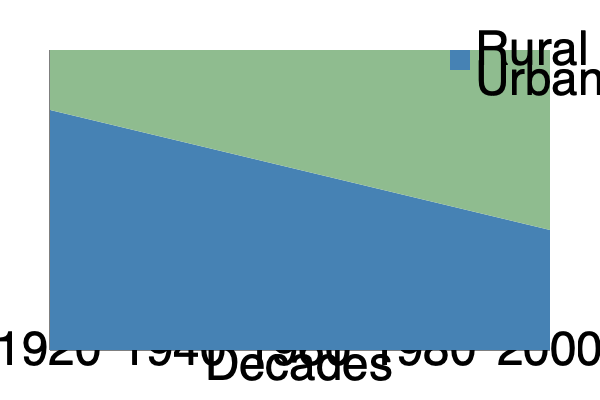Based on the stacked area chart showing the distribution of urban and rural populations from 1920 to 2000, which decade marked the turning point when the urban population surpassed the rural population in the United States? To determine when the urban population surpassed the rural population, we need to analyze the chart decade by decade:

1. 1920: The rural population (blue) is significantly larger than the urban population (green).
2. 1940: The rural population is still larger, but the gap has narrowed.
3. 1960: This appears to be the critical point. The two areas are roughly equal, with the urban area slightly larger.
4. 1980 and 2000: The urban population clearly exceeds the rural population.

The crossover point occurs around 1960, which aligns with historical data. The 1960 census was indeed the first time the urban population officially surpassed the rural population in the United States.

This shift reflects the significant demographic changes that occurred in the mid-20th century, including:

1. Industrialization and job opportunities in cities
2. Mechanization of agriculture, reducing rural labor needs
3. The post-World War II economic boom, which was centered in urban areas

As someone who lived through the Great Depression, you would have witnessed this dramatic shift in population distribution firsthand, experiencing the migration from rural to urban areas throughout your lifetime.
Answer: 1960 